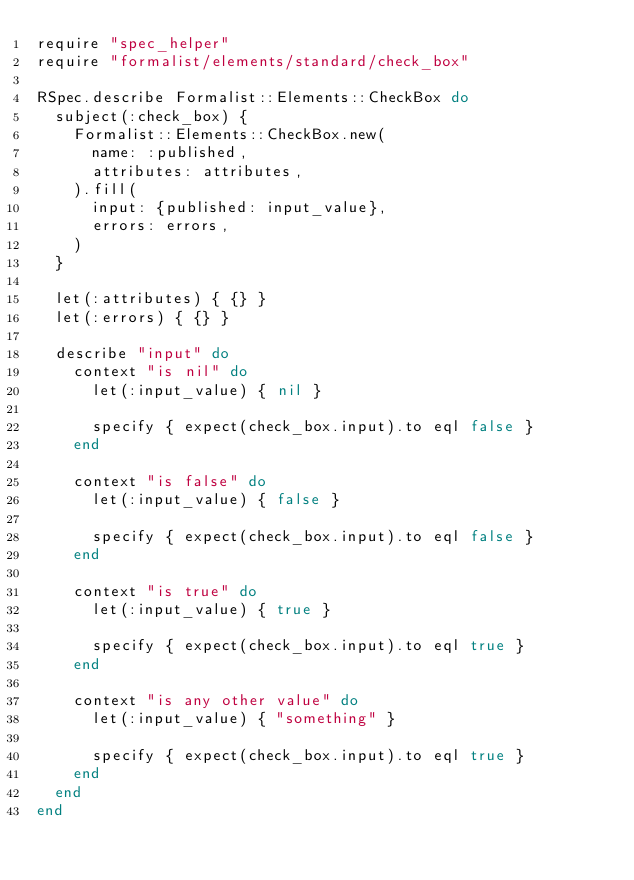Convert code to text. <code><loc_0><loc_0><loc_500><loc_500><_Ruby_>require "spec_helper"
require "formalist/elements/standard/check_box"

RSpec.describe Formalist::Elements::CheckBox do
  subject(:check_box) {
    Formalist::Elements::CheckBox.new(
      name: :published,
      attributes: attributes,
    ).fill(
      input: {published: input_value},
      errors: errors,
    )
  }

  let(:attributes) { {} }
  let(:errors) { {} }

  describe "input" do
    context "is nil" do
      let(:input_value) { nil }

      specify { expect(check_box.input).to eql false }
    end

    context "is false" do
      let(:input_value) { false }

      specify { expect(check_box.input).to eql false }
    end

    context "is true" do
      let(:input_value) { true }

      specify { expect(check_box.input).to eql true }
    end

    context "is any other value" do
      let(:input_value) { "something" }

      specify { expect(check_box.input).to eql true }
    end
  end
end
</code> 